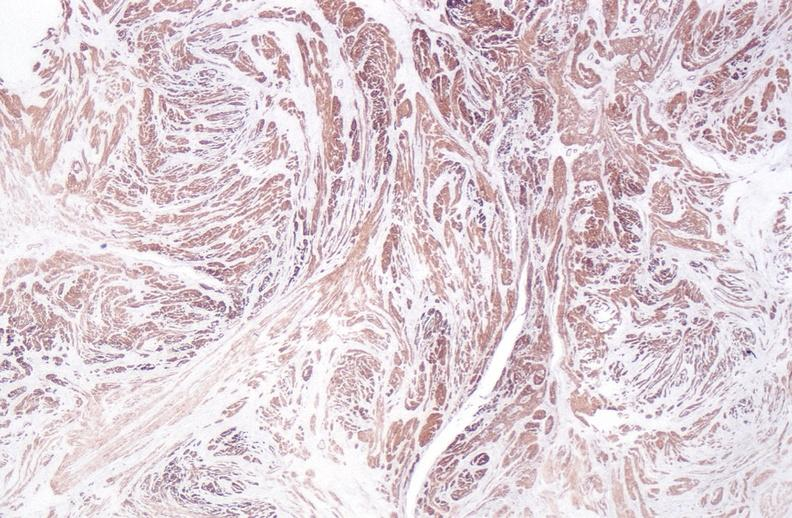s female reproductive present?
Answer the question using a single word or phrase. Yes 